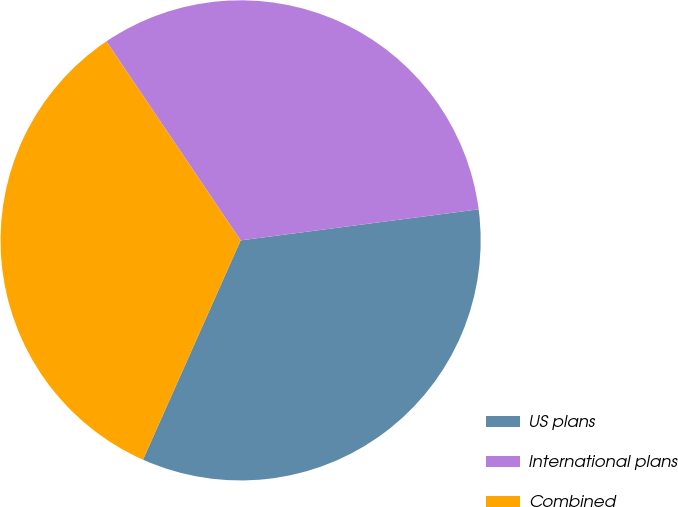Convert chart. <chart><loc_0><loc_0><loc_500><loc_500><pie_chart><fcel>US plans<fcel>International plans<fcel>Combined<nl><fcel>33.73%<fcel>32.38%<fcel>33.89%<nl></chart> 